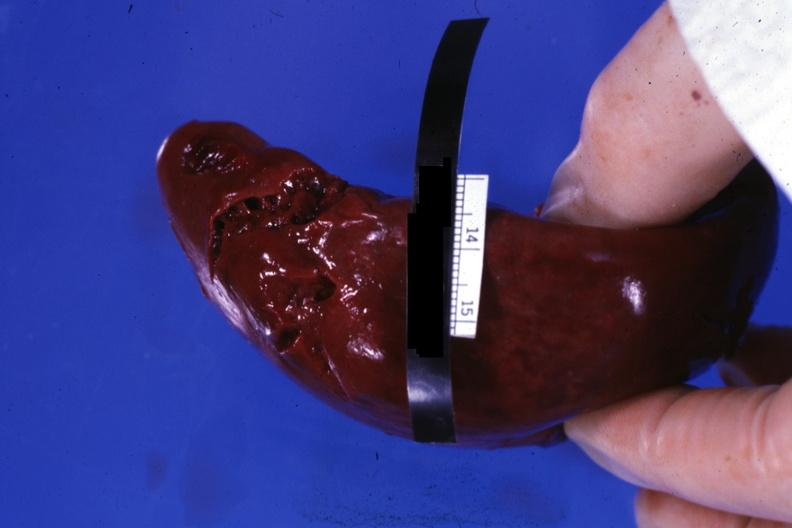s spleen present?
Answer the question using a single word or phrase. Yes 